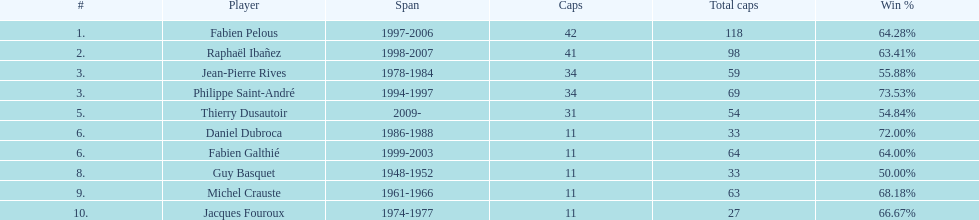What is the number of players with spans longer than three years? 6. 